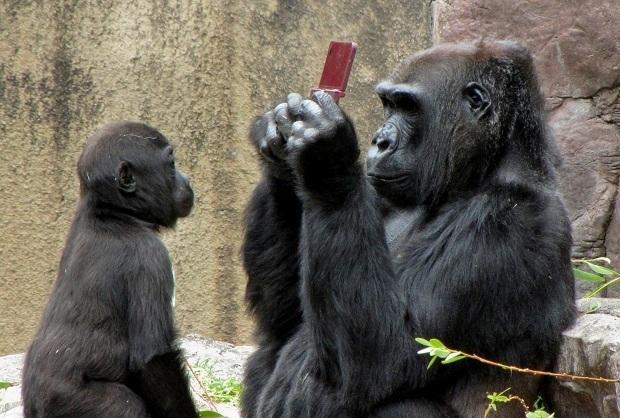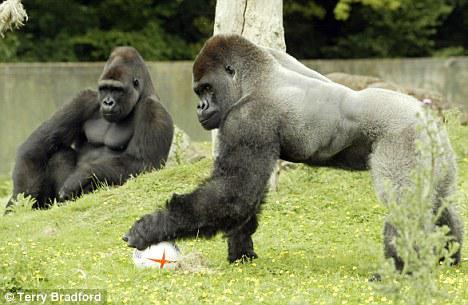The first image is the image on the left, the second image is the image on the right. Given the left and right images, does the statement "A gorilla is holding onto something round and manmade, with a cross-shape on it." hold true? Answer yes or no. Yes. The first image is the image on the left, the second image is the image on the right. For the images displayed, is the sentence "A primate is holding a ball in one of the images." factually correct? Answer yes or no. Yes. 